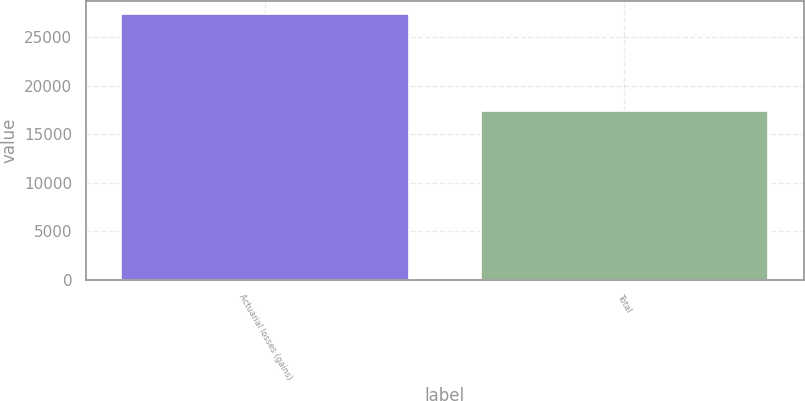Convert chart to OTSL. <chart><loc_0><loc_0><loc_500><loc_500><bar_chart><fcel>Actuarial losses (gains)<fcel>Total<nl><fcel>27398<fcel>17366<nl></chart> 